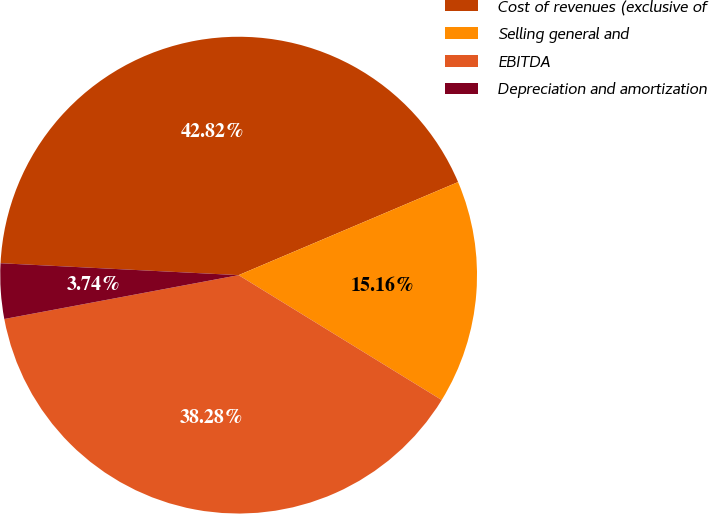Convert chart to OTSL. <chart><loc_0><loc_0><loc_500><loc_500><pie_chart><fcel>Cost of revenues (exclusive of<fcel>Selling general and<fcel>EBITDA<fcel>Depreciation and amortization<nl><fcel>42.82%<fcel>15.16%<fcel>38.28%<fcel>3.74%<nl></chart> 